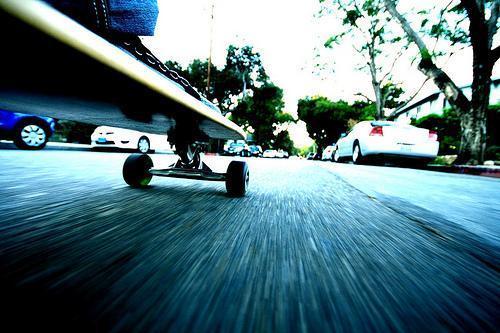How many people are there?
Give a very brief answer. 1. 